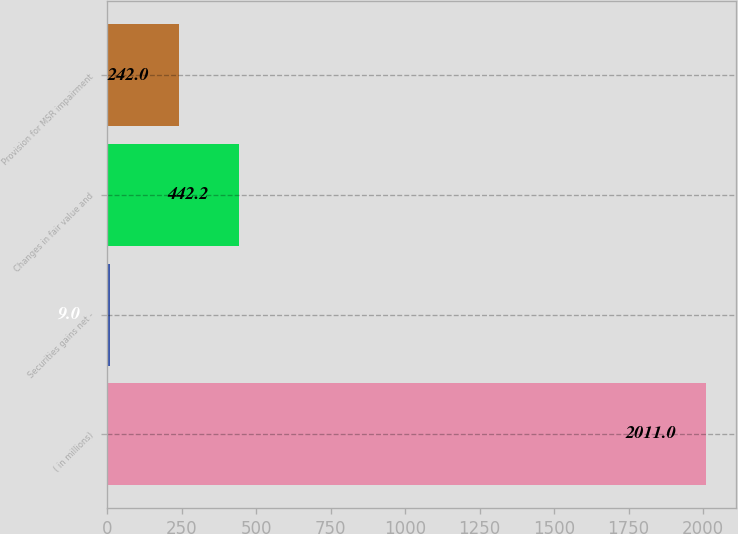Convert chart to OTSL. <chart><loc_0><loc_0><loc_500><loc_500><bar_chart><fcel>( in millions)<fcel>Securities gains net -<fcel>Changes in fair value and<fcel>Provision for MSR impairment<nl><fcel>2011<fcel>9<fcel>442.2<fcel>242<nl></chart> 